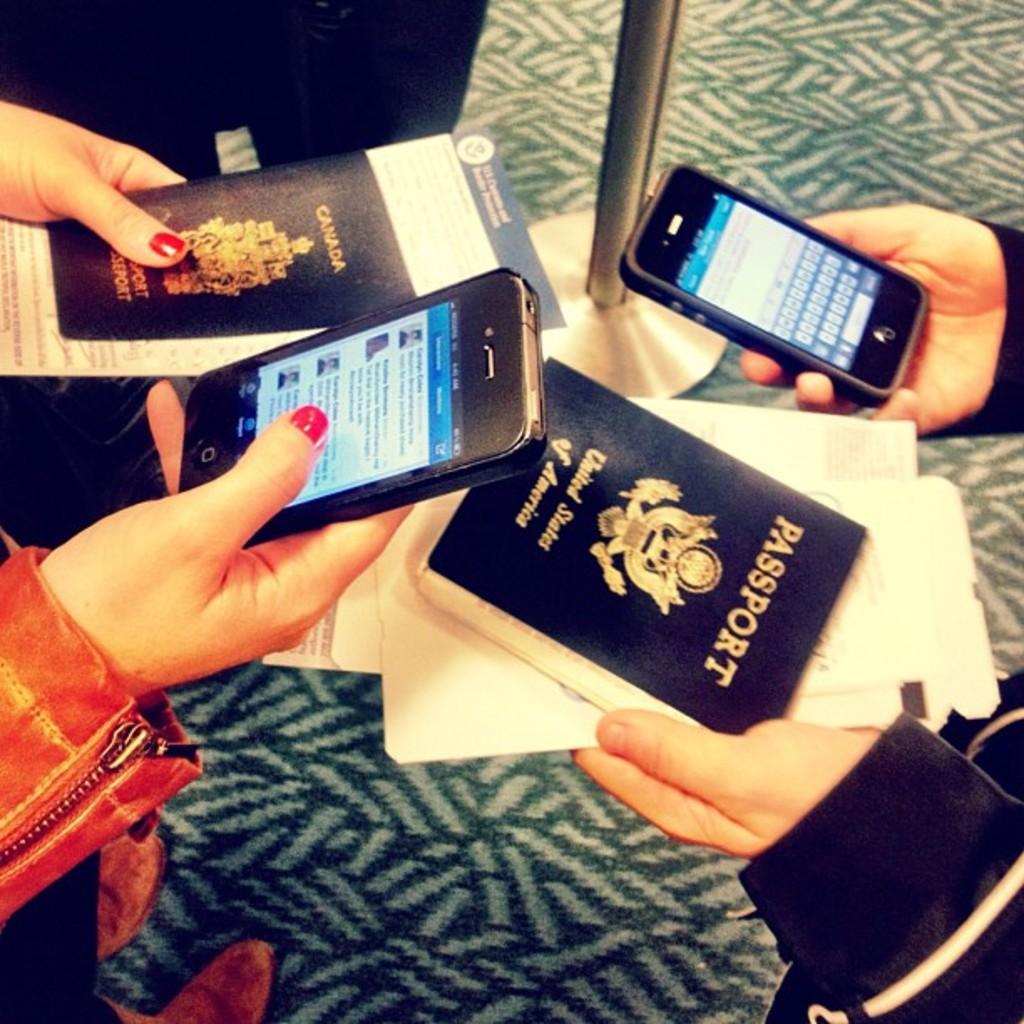What country is the passport on the top left for?
Ensure brevity in your answer.  Canada. What countries passport is the person on the right holding?
Offer a terse response. United states of america. 